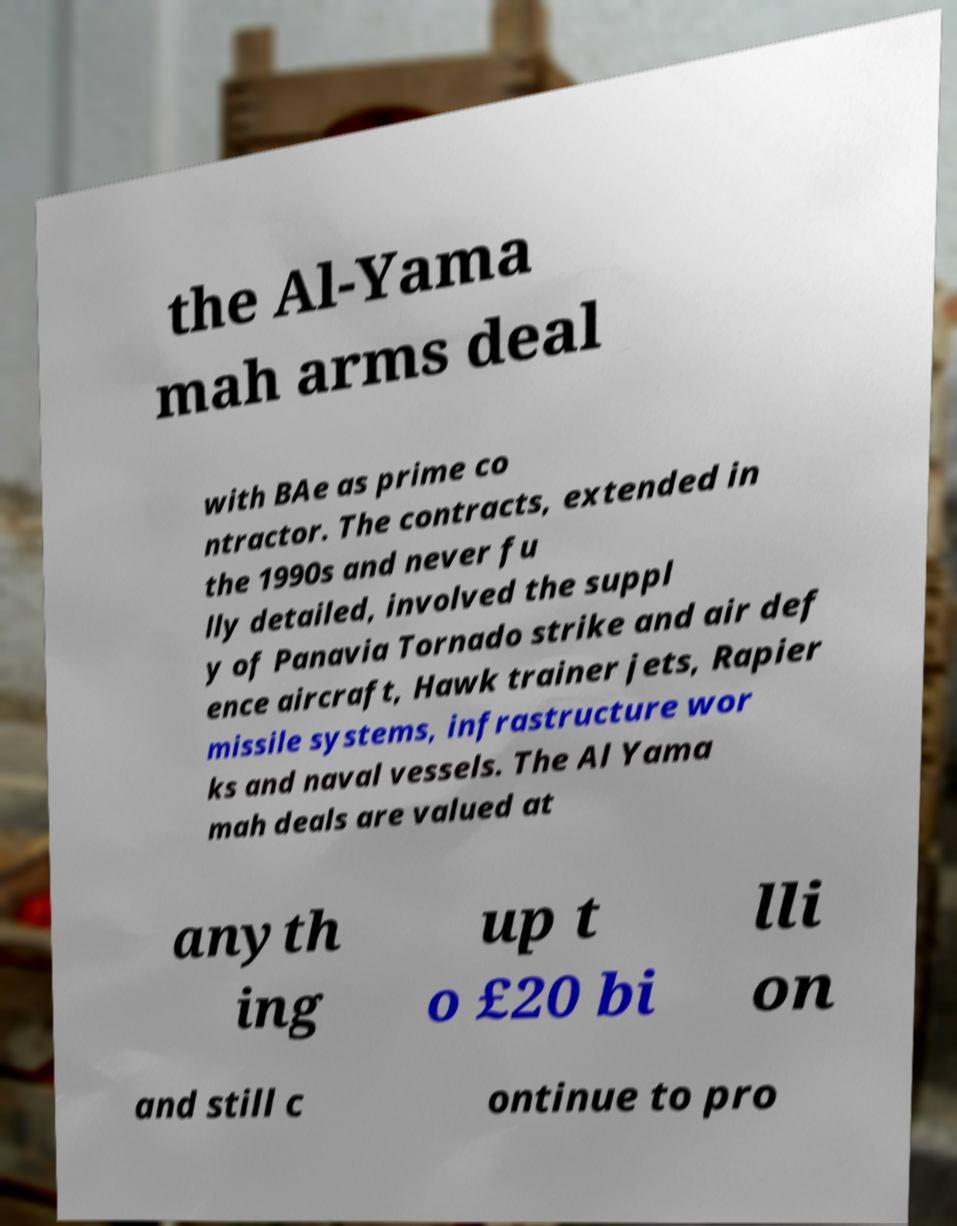Could you assist in decoding the text presented in this image and type it out clearly? the Al-Yama mah arms deal with BAe as prime co ntractor. The contracts, extended in the 1990s and never fu lly detailed, involved the suppl y of Panavia Tornado strike and air def ence aircraft, Hawk trainer jets, Rapier missile systems, infrastructure wor ks and naval vessels. The Al Yama mah deals are valued at anyth ing up t o £20 bi lli on and still c ontinue to pro 